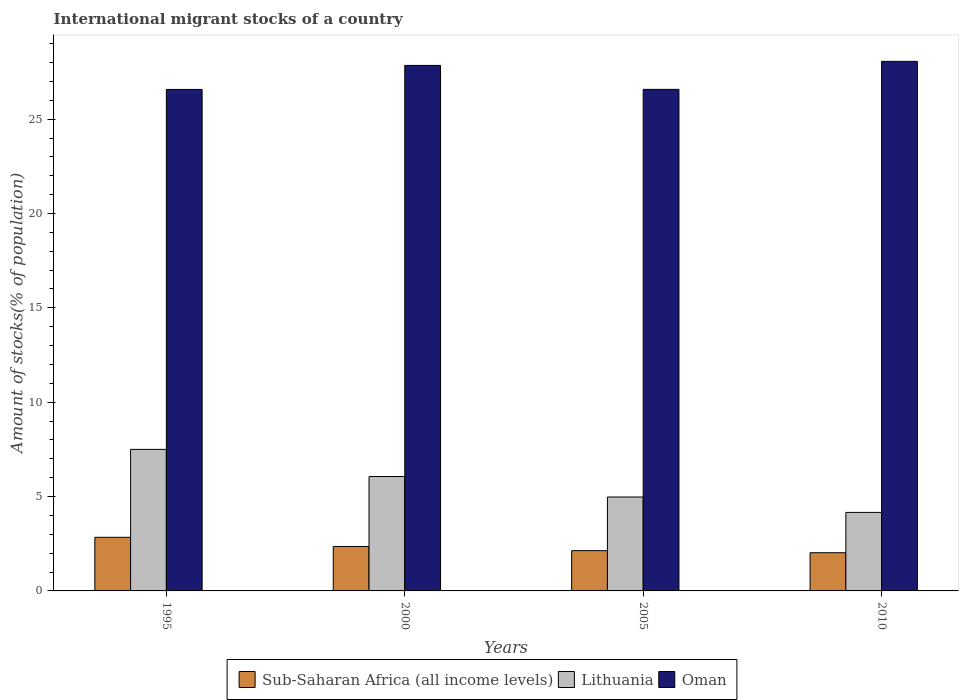How many groups of bars are there?
Provide a short and direct response. 4. Are the number of bars on each tick of the X-axis equal?
Your answer should be very brief. Yes. How many bars are there on the 4th tick from the right?
Provide a short and direct response. 3. What is the amount of stocks in in Sub-Saharan Africa (all income levels) in 2000?
Your answer should be very brief. 2.36. Across all years, what is the maximum amount of stocks in in Oman?
Provide a short and direct response. 28.06. Across all years, what is the minimum amount of stocks in in Sub-Saharan Africa (all income levels)?
Offer a terse response. 2.02. What is the total amount of stocks in in Oman in the graph?
Your answer should be very brief. 109.06. What is the difference between the amount of stocks in in Lithuania in 2000 and that in 2010?
Your response must be concise. 1.9. What is the difference between the amount of stocks in in Lithuania in 2005 and the amount of stocks in in Sub-Saharan Africa (all income levels) in 1995?
Keep it short and to the point. 2.13. What is the average amount of stocks in in Oman per year?
Your answer should be very brief. 27.27. In the year 2010, what is the difference between the amount of stocks in in Oman and amount of stocks in in Sub-Saharan Africa (all income levels)?
Offer a terse response. 26.04. What is the ratio of the amount of stocks in in Lithuania in 1995 to that in 2010?
Ensure brevity in your answer.  1.8. Is the difference between the amount of stocks in in Oman in 1995 and 2000 greater than the difference between the amount of stocks in in Sub-Saharan Africa (all income levels) in 1995 and 2000?
Make the answer very short. No. What is the difference between the highest and the second highest amount of stocks in in Lithuania?
Your answer should be compact. 1.44. What is the difference between the highest and the lowest amount of stocks in in Oman?
Your answer should be very brief. 1.49. What does the 3rd bar from the left in 2000 represents?
Your answer should be very brief. Oman. What does the 3rd bar from the right in 2010 represents?
Provide a succinct answer. Sub-Saharan Africa (all income levels). Is it the case that in every year, the sum of the amount of stocks in in Oman and amount of stocks in in Sub-Saharan Africa (all income levels) is greater than the amount of stocks in in Lithuania?
Your response must be concise. Yes. How many bars are there?
Provide a succinct answer. 12. Are all the bars in the graph horizontal?
Your answer should be compact. No. How many years are there in the graph?
Provide a succinct answer. 4. What is the difference between two consecutive major ticks on the Y-axis?
Make the answer very short. 5. Does the graph contain grids?
Offer a very short reply. No. How are the legend labels stacked?
Offer a terse response. Horizontal. What is the title of the graph?
Provide a short and direct response. International migrant stocks of a country. What is the label or title of the X-axis?
Offer a very short reply. Years. What is the label or title of the Y-axis?
Your answer should be compact. Amount of stocks(% of population). What is the Amount of stocks(% of population) of Sub-Saharan Africa (all income levels) in 1995?
Your answer should be very brief. 2.84. What is the Amount of stocks(% of population) of Lithuania in 1995?
Make the answer very short. 7.5. What is the Amount of stocks(% of population) of Oman in 1995?
Make the answer very short. 26.57. What is the Amount of stocks(% of population) of Sub-Saharan Africa (all income levels) in 2000?
Your response must be concise. 2.36. What is the Amount of stocks(% of population) of Lithuania in 2000?
Offer a terse response. 6.06. What is the Amount of stocks(% of population) of Oman in 2000?
Make the answer very short. 27.85. What is the Amount of stocks(% of population) of Sub-Saharan Africa (all income levels) in 2005?
Ensure brevity in your answer.  2.13. What is the Amount of stocks(% of population) in Lithuania in 2005?
Ensure brevity in your answer.  4.98. What is the Amount of stocks(% of population) in Oman in 2005?
Your answer should be very brief. 26.58. What is the Amount of stocks(% of population) of Sub-Saharan Africa (all income levels) in 2010?
Your response must be concise. 2.02. What is the Amount of stocks(% of population) of Lithuania in 2010?
Offer a very short reply. 4.16. What is the Amount of stocks(% of population) of Oman in 2010?
Your answer should be very brief. 28.06. Across all years, what is the maximum Amount of stocks(% of population) in Sub-Saharan Africa (all income levels)?
Offer a very short reply. 2.84. Across all years, what is the maximum Amount of stocks(% of population) of Lithuania?
Offer a very short reply. 7.5. Across all years, what is the maximum Amount of stocks(% of population) of Oman?
Your answer should be very brief. 28.06. Across all years, what is the minimum Amount of stocks(% of population) in Sub-Saharan Africa (all income levels)?
Make the answer very short. 2.02. Across all years, what is the minimum Amount of stocks(% of population) of Lithuania?
Keep it short and to the point. 4.16. Across all years, what is the minimum Amount of stocks(% of population) in Oman?
Provide a short and direct response. 26.57. What is the total Amount of stocks(% of population) of Sub-Saharan Africa (all income levels) in the graph?
Ensure brevity in your answer.  9.35. What is the total Amount of stocks(% of population) in Lithuania in the graph?
Your answer should be compact. 22.7. What is the total Amount of stocks(% of population) in Oman in the graph?
Offer a very short reply. 109.06. What is the difference between the Amount of stocks(% of population) of Sub-Saharan Africa (all income levels) in 1995 and that in 2000?
Your answer should be compact. 0.49. What is the difference between the Amount of stocks(% of population) in Lithuania in 1995 and that in 2000?
Provide a short and direct response. 1.44. What is the difference between the Amount of stocks(% of population) in Oman in 1995 and that in 2000?
Provide a succinct answer. -1.27. What is the difference between the Amount of stocks(% of population) of Sub-Saharan Africa (all income levels) in 1995 and that in 2005?
Keep it short and to the point. 0.71. What is the difference between the Amount of stocks(% of population) of Lithuania in 1995 and that in 2005?
Your answer should be very brief. 2.52. What is the difference between the Amount of stocks(% of population) in Oman in 1995 and that in 2005?
Provide a succinct answer. -0. What is the difference between the Amount of stocks(% of population) of Sub-Saharan Africa (all income levels) in 1995 and that in 2010?
Offer a very short reply. 0.82. What is the difference between the Amount of stocks(% of population) of Lithuania in 1995 and that in 2010?
Offer a very short reply. 3.34. What is the difference between the Amount of stocks(% of population) in Oman in 1995 and that in 2010?
Your answer should be compact. -1.49. What is the difference between the Amount of stocks(% of population) in Sub-Saharan Africa (all income levels) in 2000 and that in 2005?
Provide a short and direct response. 0.22. What is the difference between the Amount of stocks(% of population) in Lithuania in 2000 and that in 2005?
Offer a very short reply. 1.09. What is the difference between the Amount of stocks(% of population) of Oman in 2000 and that in 2005?
Your answer should be very brief. 1.27. What is the difference between the Amount of stocks(% of population) of Sub-Saharan Africa (all income levels) in 2000 and that in 2010?
Offer a very short reply. 0.33. What is the difference between the Amount of stocks(% of population) in Lithuania in 2000 and that in 2010?
Offer a very short reply. 1.9. What is the difference between the Amount of stocks(% of population) in Oman in 2000 and that in 2010?
Your response must be concise. -0.21. What is the difference between the Amount of stocks(% of population) of Sub-Saharan Africa (all income levels) in 2005 and that in 2010?
Give a very brief answer. 0.11. What is the difference between the Amount of stocks(% of population) of Lithuania in 2005 and that in 2010?
Your answer should be very brief. 0.82. What is the difference between the Amount of stocks(% of population) in Oman in 2005 and that in 2010?
Ensure brevity in your answer.  -1.48. What is the difference between the Amount of stocks(% of population) of Sub-Saharan Africa (all income levels) in 1995 and the Amount of stocks(% of population) of Lithuania in 2000?
Your answer should be very brief. -3.22. What is the difference between the Amount of stocks(% of population) of Sub-Saharan Africa (all income levels) in 1995 and the Amount of stocks(% of population) of Oman in 2000?
Offer a very short reply. -25.01. What is the difference between the Amount of stocks(% of population) of Lithuania in 1995 and the Amount of stocks(% of population) of Oman in 2000?
Provide a succinct answer. -20.35. What is the difference between the Amount of stocks(% of population) of Sub-Saharan Africa (all income levels) in 1995 and the Amount of stocks(% of population) of Lithuania in 2005?
Provide a short and direct response. -2.13. What is the difference between the Amount of stocks(% of population) of Sub-Saharan Africa (all income levels) in 1995 and the Amount of stocks(% of population) of Oman in 2005?
Make the answer very short. -23.74. What is the difference between the Amount of stocks(% of population) of Lithuania in 1995 and the Amount of stocks(% of population) of Oman in 2005?
Ensure brevity in your answer.  -19.08. What is the difference between the Amount of stocks(% of population) of Sub-Saharan Africa (all income levels) in 1995 and the Amount of stocks(% of population) of Lithuania in 2010?
Your answer should be compact. -1.32. What is the difference between the Amount of stocks(% of population) in Sub-Saharan Africa (all income levels) in 1995 and the Amount of stocks(% of population) in Oman in 2010?
Ensure brevity in your answer.  -25.22. What is the difference between the Amount of stocks(% of population) in Lithuania in 1995 and the Amount of stocks(% of population) in Oman in 2010?
Make the answer very short. -20.56. What is the difference between the Amount of stocks(% of population) in Sub-Saharan Africa (all income levels) in 2000 and the Amount of stocks(% of population) in Lithuania in 2005?
Your response must be concise. -2.62. What is the difference between the Amount of stocks(% of population) of Sub-Saharan Africa (all income levels) in 2000 and the Amount of stocks(% of population) of Oman in 2005?
Your response must be concise. -24.22. What is the difference between the Amount of stocks(% of population) of Lithuania in 2000 and the Amount of stocks(% of population) of Oman in 2005?
Offer a very short reply. -20.52. What is the difference between the Amount of stocks(% of population) in Sub-Saharan Africa (all income levels) in 2000 and the Amount of stocks(% of population) in Lithuania in 2010?
Offer a very short reply. -1.8. What is the difference between the Amount of stocks(% of population) in Sub-Saharan Africa (all income levels) in 2000 and the Amount of stocks(% of population) in Oman in 2010?
Offer a very short reply. -25.71. What is the difference between the Amount of stocks(% of population) of Lithuania in 2000 and the Amount of stocks(% of population) of Oman in 2010?
Ensure brevity in your answer.  -22. What is the difference between the Amount of stocks(% of population) of Sub-Saharan Africa (all income levels) in 2005 and the Amount of stocks(% of population) of Lithuania in 2010?
Ensure brevity in your answer.  -2.03. What is the difference between the Amount of stocks(% of population) in Sub-Saharan Africa (all income levels) in 2005 and the Amount of stocks(% of population) in Oman in 2010?
Provide a short and direct response. -25.93. What is the difference between the Amount of stocks(% of population) of Lithuania in 2005 and the Amount of stocks(% of population) of Oman in 2010?
Ensure brevity in your answer.  -23.09. What is the average Amount of stocks(% of population) of Sub-Saharan Africa (all income levels) per year?
Offer a terse response. 2.34. What is the average Amount of stocks(% of population) of Lithuania per year?
Offer a terse response. 5.67. What is the average Amount of stocks(% of population) of Oman per year?
Your answer should be very brief. 27.27. In the year 1995, what is the difference between the Amount of stocks(% of population) of Sub-Saharan Africa (all income levels) and Amount of stocks(% of population) of Lithuania?
Keep it short and to the point. -4.66. In the year 1995, what is the difference between the Amount of stocks(% of population) in Sub-Saharan Africa (all income levels) and Amount of stocks(% of population) in Oman?
Your answer should be very brief. -23.73. In the year 1995, what is the difference between the Amount of stocks(% of population) in Lithuania and Amount of stocks(% of population) in Oman?
Provide a short and direct response. -19.07. In the year 2000, what is the difference between the Amount of stocks(% of population) of Sub-Saharan Africa (all income levels) and Amount of stocks(% of population) of Lithuania?
Offer a very short reply. -3.71. In the year 2000, what is the difference between the Amount of stocks(% of population) in Sub-Saharan Africa (all income levels) and Amount of stocks(% of population) in Oman?
Provide a succinct answer. -25.49. In the year 2000, what is the difference between the Amount of stocks(% of population) in Lithuania and Amount of stocks(% of population) in Oman?
Provide a short and direct response. -21.79. In the year 2005, what is the difference between the Amount of stocks(% of population) in Sub-Saharan Africa (all income levels) and Amount of stocks(% of population) in Lithuania?
Provide a succinct answer. -2.84. In the year 2005, what is the difference between the Amount of stocks(% of population) of Sub-Saharan Africa (all income levels) and Amount of stocks(% of population) of Oman?
Give a very brief answer. -24.44. In the year 2005, what is the difference between the Amount of stocks(% of population) of Lithuania and Amount of stocks(% of population) of Oman?
Make the answer very short. -21.6. In the year 2010, what is the difference between the Amount of stocks(% of population) in Sub-Saharan Africa (all income levels) and Amount of stocks(% of population) in Lithuania?
Give a very brief answer. -2.14. In the year 2010, what is the difference between the Amount of stocks(% of population) of Sub-Saharan Africa (all income levels) and Amount of stocks(% of population) of Oman?
Make the answer very short. -26.04. In the year 2010, what is the difference between the Amount of stocks(% of population) of Lithuania and Amount of stocks(% of population) of Oman?
Provide a succinct answer. -23.9. What is the ratio of the Amount of stocks(% of population) of Sub-Saharan Africa (all income levels) in 1995 to that in 2000?
Provide a succinct answer. 1.21. What is the ratio of the Amount of stocks(% of population) of Lithuania in 1995 to that in 2000?
Your response must be concise. 1.24. What is the ratio of the Amount of stocks(% of population) of Oman in 1995 to that in 2000?
Your answer should be compact. 0.95. What is the ratio of the Amount of stocks(% of population) in Sub-Saharan Africa (all income levels) in 1995 to that in 2005?
Make the answer very short. 1.33. What is the ratio of the Amount of stocks(% of population) in Lithuania in 1995 to that in 2005?
Give a very brief answer. 1.51. What is the ratio of the Amount of stocks(% of population) of Oman in 1995 to that in 2005?
Your answer should be very brief. 1. What is the ratio of the Amount of stocks(% of population) of Sub-Saharan Africa (all income levels) in 1995 to that in 2010?
Provide a succinct answer. 1.4. What is the ratio of the Amount of stocks(% of population) of Lithuania in 1995 to that in 2010?
Your answer should be compact. 1.8. What is the ratio of the Amount of stocks(% of population) in Oman in 1995 to that in 2010?
Provide a short and direct response. 0.95. What is the ratio of the Amount of stocks(% of population) in Sub-Saharan Africa (all income levels) in 2000 to that in 2005?
Offer a very short reply. 1.1. What is the ratio of the Amount of stocks(% of population) in Lithuania in 2000 to that in 2005?
Ensure brevity in your answer.  1.22. What is the ratio of the Amount of stocks(% of population) in Oman in 2000 to that in 2005?
Provide a succinct answer. 1.05. What is the ratio of the Amount of stocks(% of population) in Sub-Saharan Africa (all income levels) in 2000 to that in 2010?
Ensure brevity in your answer.  1.16. What is the ratio of the Amount of stocks(% of population) in Lithuania in 2000 to that in 2010?
Provide a short and direct response. 1.46. What is the ratio of the Amount of stocks(% of population) in Oman in 2000 to that in 2010?
Your answer should be compact. 0.99. What is the ratio of the Amount of stocks(% of population) in Sub-Saharan Africa (all income levels) in 2005 to that in 2010?
Ensure brevity in your answer.  1.05. What is the ratio of the Amount of stocks(% of population) of Lithuania in 2005 to that in 2010?
Offer a terse response. 1.2. What is the ratio of the Amount of stocks(% of population) of Oman in 2005 to that in 2010?
Offer a terse response. 0.95. What is the difference between the highest and the second highest Amount of stocks(% of population) of Sub-Saharan Africa (all income levels)?
Keep it short and to the point. 0.49. What is the difference between the highest and the second highest Amount of stocks(% of population) in Lithuania?
Make the answer very short. 1.44. What is the difference between the highest and the second highest Amount of stocks(% of population) of Oman?
Offer a very short reply. 0.21. What is the difference between the highest and the lowest Amount of stocks(% of population) in Sub-Saharan Africa (all income levels)?
Provide a succinct answer. 0.82. What is the difference between the highest and the lowest Amount of stocks(% of population) of Lithuania?
Ensure brevity in your answer.  3.34. What is the difference between the highest and the lowest Amount of stocks(% of population) of Oman?
Provide a short and direct response. 1.49. 